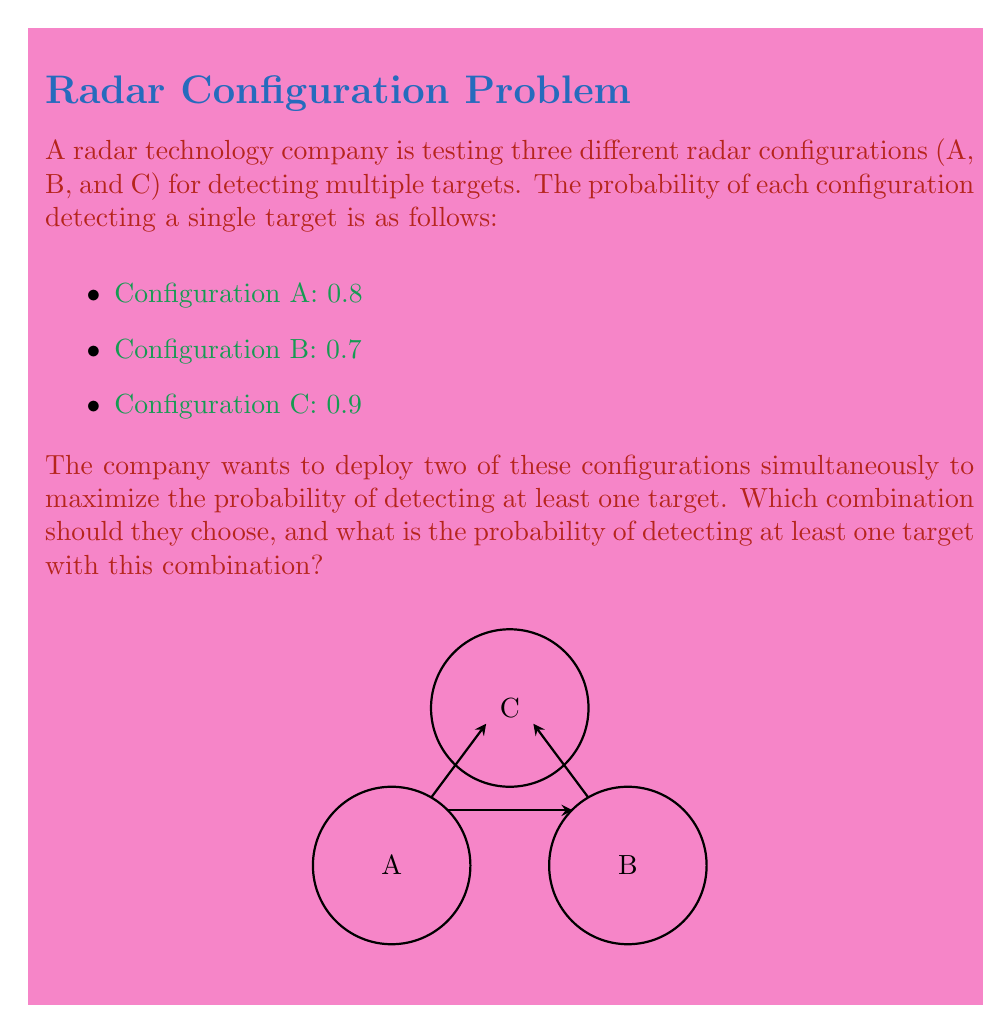Solve this math problem. To solve this problem, we need to follow these steps:

1) First, we need to calculate the probability of detecting at least one target for each possible combination of two configurations:

   For A and B: 
   $P(\text{at least one detection}) = 1 - P(\text{no detection})$
   $= 1 - (1-0.8)(1-0.7) = 1 - 0.2 \times 0.3 = 1 - 0.06 = 0.94$

   For A and C:
   $1 - (1-0.8)(1-0.9) = 1 - 0.2 \times 0.1 = 1 - 0.02 = 0.98$

   For B and C:
   $1 - (1-0.7)(1-0.9) = 1 - 0.3 \times 0.1 = 1 - 0.03 = 0.97$

2) Now, we compare these probabilities:
   A and B: 0.94
   A and C: 0.98
   B and C: 0.97

3) The highest probability is 0.98, which corresponds to the combination of configurations A and C.

Therefore, the company should choose to deploy configurations A and C simultaneously, which gives a 0.98 (or 98%) probability of detecting at least one target.
Answer: Configurations A and C; 0.98 